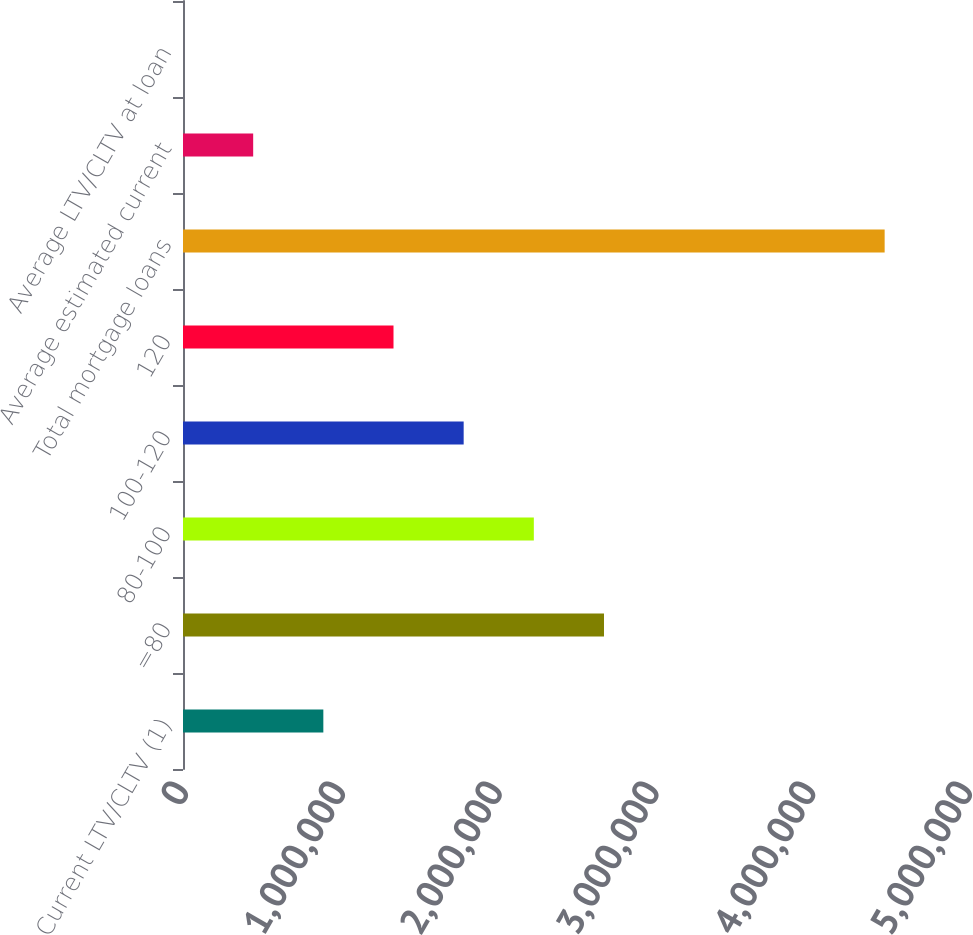<chart> <loc_0><loc_0><loc_500><loc_500><bar_chart><fcel>Current LTV/CLTV (1)<fcel>=80<fcel>80-100<fcel>100-120<fcel>120<fcel>Total mortgage loans<fcel>Average estimated current<fcel>Average LTV/CLTV at loan<nl><fcel>895016<fcel>2.6849e+06<fcel>2.23743e+06<fcel>1.78996e+06<fcel>1.34249e+06<fcel>4.47479e+06<fcel>447544<fcel>71.5<nl></chart> 